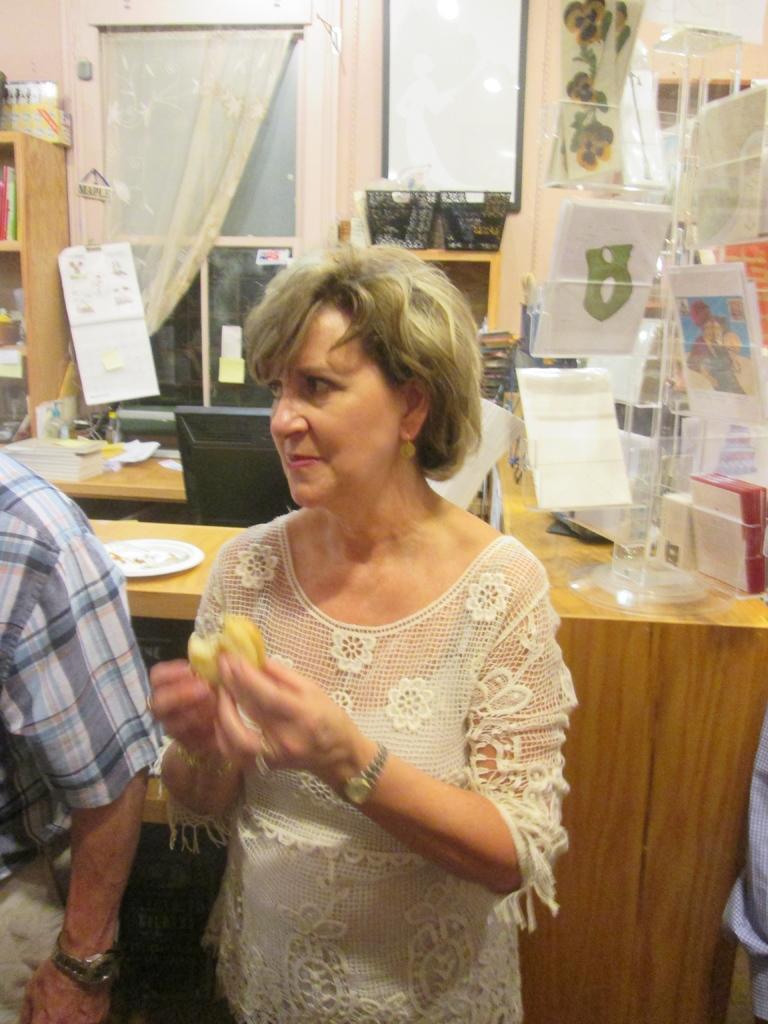How would you summarize this image in a sentence or two? In this picture I can see a woman is standing and holding an object in the hand. The woman is wearing white color dress. In the background I can see windows, white color curtain and table. On the table I can see white color plate and some other objects. On the left side I can see a person. 